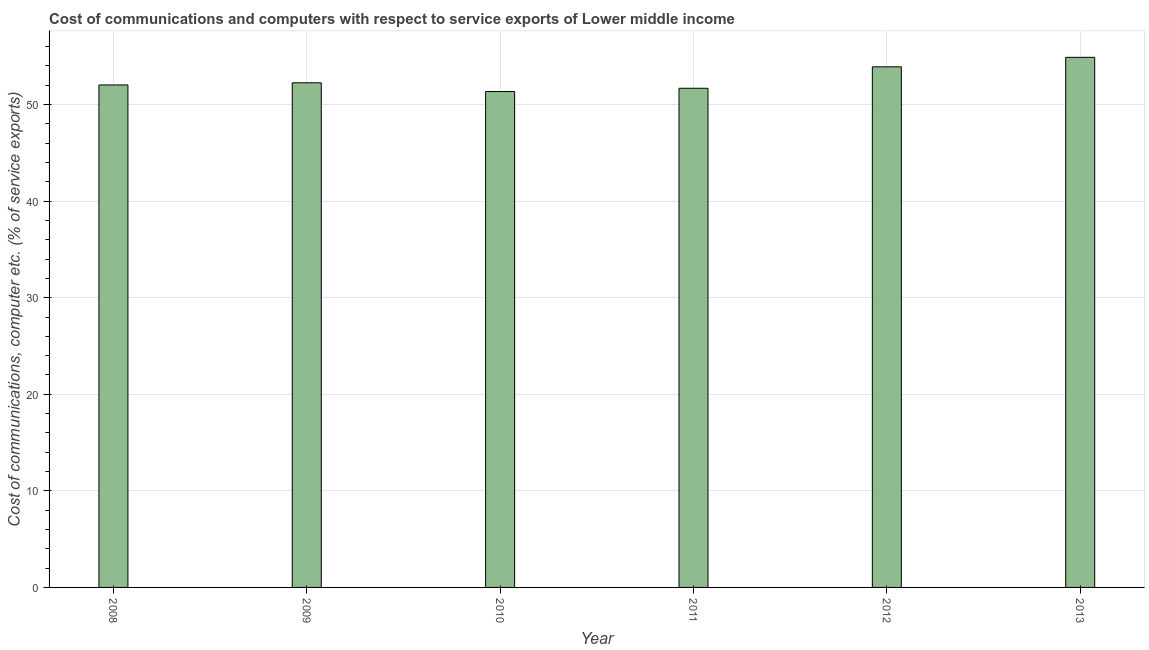Does the graph contain grids?
Your answer should be compact. Yes. What is the title of the graph?
Give a very brief answer. Cost of communications and computers with respect to service exports of Lower middle income. What is the label or title of the Y-axis?
Offer a terse response. Cost of communications, computer etc. (% of service exports). What is the cost of communications and computer in 2012?
Your response must be concise. 53.91. Across all years, what is the maximum cost of communications and computer?
Give a very brief answer. 54.89. Across all years, what is the minimum cost of communications and computer?
Offer a terse response. 51.35. In which year was the cost of communications and computer maximum?
Keep it short and to the point. 2013. What is the sum of the cost of communications and computer?
Your answer should be compact. 316.13. What is the difference between the cost of communications and computer in 2008 and 2013?
Offer a very short reply. -2.86. What is the average cost of communications and computer per year?
Your answer should be very brief. 52.69. What is the median cost of communications and computer?
Give a very brief answer. 52.14. What is the ratio of the cost of communications and computer in 2008 to that in 2009?
Your answer should be compact. 1. Is the difference between the cost of communications and computer in 2008 and 2013 greater than the difference between any two years?
Make the answer very short. No. What is the difference between the highest and the second highest cost of communications and computer?
Provide a succinct answer. 0.98. Is the sum of the cost of communications and computer in 2012 and 2013 greater than the maximum cost of communications and computer across all years?
Offer a terse response. Yes. What is the difference between the highest and the lowest cost of communications and computer?
Your response must be concise. 3.54. Are all the bars in the graph horizontal?
Provide a succinct answer. No. How many years are there in the graph?
Offer a very short reply. 6. Are the values on the major ticks of Y-axis written in scientific E-notation?
Your answer should be compact. No. What is the Cost of communications, computer etc. (% of service exports) in 2008?
Provide a succinct answer. 52.03. What is the Cost of communications, computer etc. (% of service exports) of 2009?
Offer a terse response. 52.26. What is the Cost of communications, computer etc. (% of service exports) in 2010?
Your answer should be very brief. 51.35. What is the Cost of communications, computer etc. (% of service exports) of 2011?
Ensure brevity in your answer.  51.69. What is the Cost of communications, computer etc. (% of service exports) of 2012?
Your answer should be very brief. 53.91. What is the Cost of communications, computer etc. (% of service exports) in 2013?
Your response must be concise. 54.89. What is the difference between the Cost of communications, computer etc. (% of service exports) in 2008 and 2009?
Provide a succinct answer. -0.23. What is the difference between the Cost of communications, computer etc. (% of service exports) in 2008 and 2010?
Your response must be concise. 0.68. What is the difference between the Cost of communications, computer etc. (% of service exports) in 2008 and 2011?
Provide a succinct answer. 0.34. What is the difference between the Cost of communications, computer etc. (% of service exports) in 2008 and 2012?
Your response must be concise. -1.88. What is the difference between the Cost of communications, computer etc. (% of service exports) in 2008 and 2013?
Your response must be concise. -2.86. What is the difference between the Cost of communications, computer etc. (% of service exports) in 2009 and 2010?
Offer a terse response. 0.91. What is the difference between the Cost of communications, computer etc. (% of service exports) in 2009 and 2011?
Your answer should be very brief. 0.57. What is the difference between the Cost of communications, computer etc. (% of service exports) in 2009 and 2012?
Offer a very short reply. -1.65. What is the difference between the Cost of communications, computer etc. (% of service exports) in 2009 and 2013?
Make the answer very short. -2.64. What is the difference between the Cost of communications, computer etc. (% of service exports) in 2010 and 2011?
Give a very brief answer. -0.34. What is the difference between the Cost of communications, computer etc. (% of service exports) in 2010 and 2012?
Offer a very short reply. -2.56. What is the difference between the Cost of communications, computer etc. (% of service exports) in 2010 and 2013?
Provide a short and direct response. -3.54. What is the difference between the Cost of communications, computer etc. (% of service exports) in 2011 and 2012?
Your answer should be very brief. -2.22. What is the difference between the Cost of communications, computer etc. (% of service exports) in 2011 and 2013?
Offer a terse response. -3.2. What is the difference between the Cost of communications, computer etc. (% of service exports) in 2012 and 2013?
Provide a succinct answer. -0.98. What is the ratio of the Cost of communications, computer etc. (% of service exports) in 2008 to that in 2009?
Your answer should be very brief. 1. What is the ratio of the Cost of communications, computer etc. (% of service exports) in 2008 to that in 2010?
Provide a short and direct response. 1.01. What is the ratio of the Cost of communications, computer etc. (% of service exports) in 2008 to that in 2011?
Your answer should be very brief. 1.01. What is the ratio of the Cost of communications, computer etc. (% of service exports) in 2008 to that in 2012?
Keep it short and to the point. 0.96. What is the ratio of the Cost of communications, computer etc. (% of service exports) in 2008 to that in 2013?
Give a very brief answer. 0.95. What is the ratio of the Cost of communications, computer etc. (% of service exports) in 2009 to that in 2010?
Keep it short and to the point. 1.02. What is the ratio of the Cost of communications, computer etc. (% of service exports) in 2009 to that in 2013?
Give a very brief answer. 0.95. What is the ratio of the Cost of communications, computer etc. (% of service exports) in 2010 to that in 2011?
Your response must be concise. 0.99. What is the ratio of the Cost of communications, computer etc. (% of service exports) in 2010 to that in 2012?
Offer a very short reply. 0.95. What is the ratio of the Cost of communications, computer etc. (% of service exports) in 2010 to that in 2013?
Keep it short and to the point. 0.94. What is the ratio of the Cost of communications, computer etc. (% of service exports) in 2011 to that in 2012?
Offer a very short reply. 0.96. What is the ratio of the Cost of communications, computer etc. (% of service exports) in 2011 to that in 2013?
Make the answer very short. 0.94. What is the ratio of the Cost of communications, computer etc. (% of service exports) in 2012 to that in 2013?
Keep it short and to the point. 0.98. 